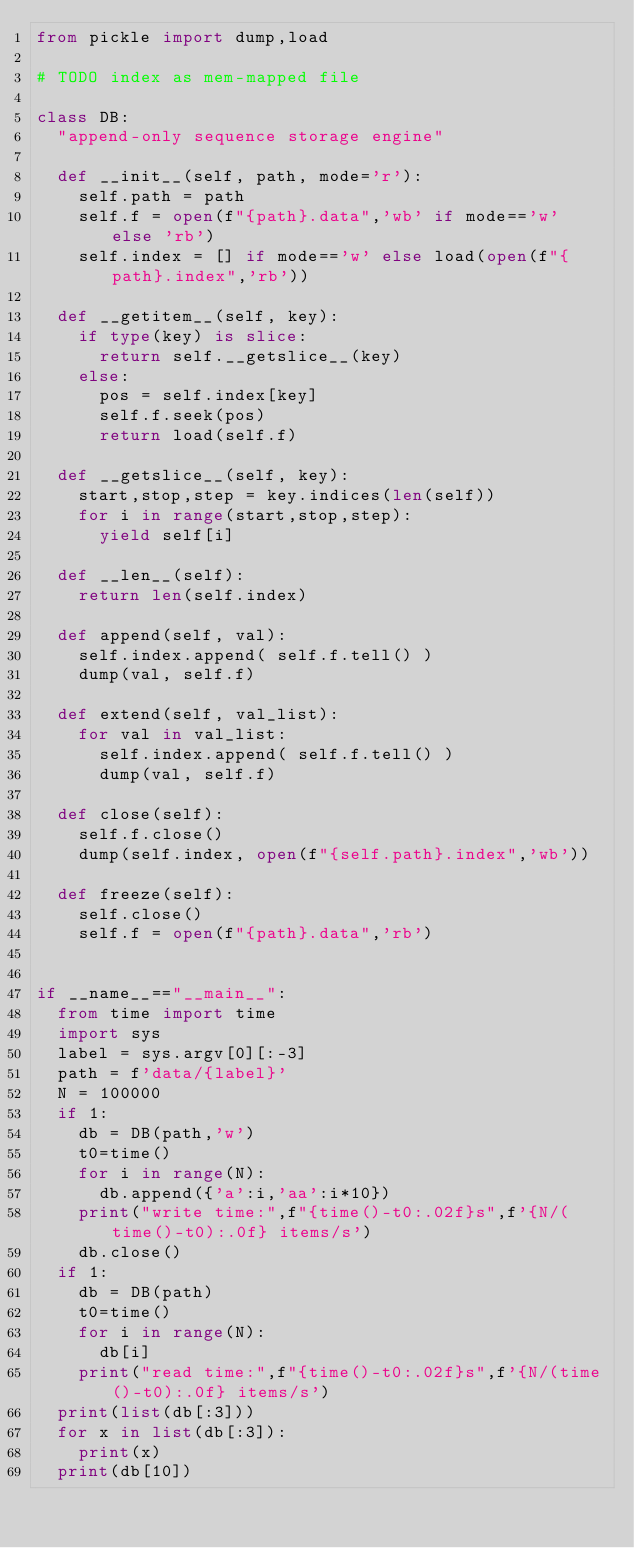<code> <loc_0><loc_0><loc_500><loc_500><_Python_>from pickle import dump,load

# TODO index as mem-mapped file

class DB:
	"append-only sequence storage engine"
	
	def __init__(self, path, mode='r'):
		self.path = path
		self.f = open(f"{path}.data",'wb' if mode=='w' else 'rb')
		self.index = [] if mode=='w' else load(open(f"{path}.index",'rb'))
	
	def __getitem__(self, key):
		if type(key) is slice:
			return self.__getslice__(key)
		else:
			pos = self.index[key]
			self.f.seek(pos)
			return load(self.f)
	
	def __getslice__(self, key):
		start,stop,step = key.indices(len(self))
		for i in range(start,stop,step):
			yield self[i]
	
	def __len__(self):
		return len(self.index)
	
	def append(self, val):
		self.index.append( self.f.tell() )
		dump(val, self.f)
	
	def extend(self, val_list):
		for val in val_list:
			self.index.append( self.f.tell() )
			dump(val, self.f)

	def close(self):
		self.f.close()
		dump(self.index, open(f"{self.path}.index",'wb'))
	
	def freeze(self):
		self.close()
		self.f = open(f"{path}.data",'rb')


if __name__=="__main__":
	from time import time
	import sys
	label = sys.argv[0][:-3]
	path = f'data/{label}'
	N = 100000
	if 1:
		db = DB(path,'w')
		t0=time()
		for i in range(N):
			db.append({'a':i,'aa':i*10})
		print("write time:",f"{time()-t0:.02f}s",f'{N/(time()-t0):.0f} items/s')
		db.close()
	if 1:
		db = DB(path)
		t0=time()
		for i in range(N):
			db[i]
		print("read time:",f"{time()-t0:.02f}s",f'{N/(time()-t0):.0f} items/s')
	print(list(db[:3]))
	for x in list(db[:3]):
		print(x)
	print(db[10])
</code> 